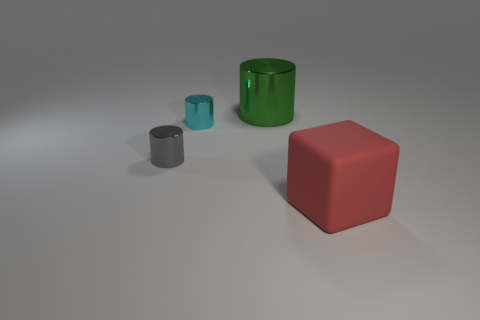What objects are present in the image, and what colors are they? The image contains four objects: a large cyan cylinder with a matte finish, a small grey cylinder, a medium-sized teal cylinder, and a matte red cube. 